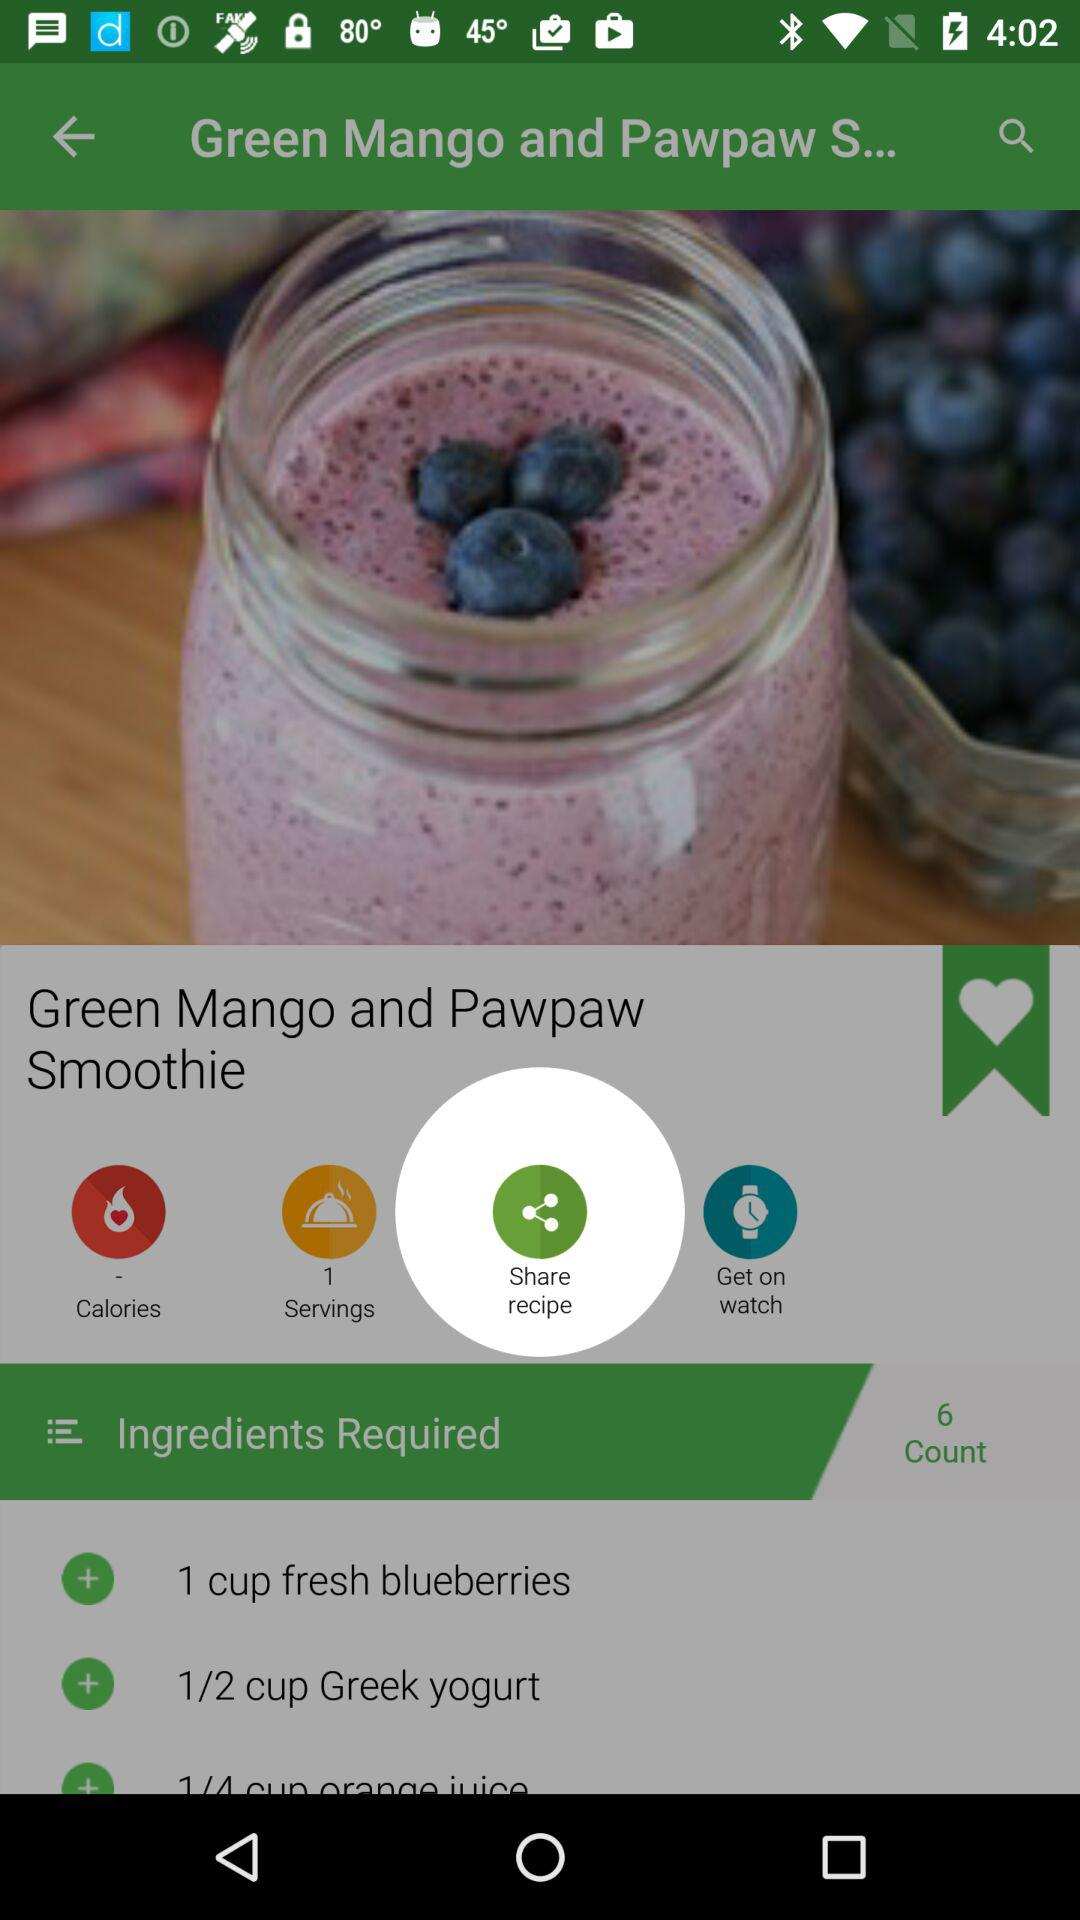What is the count? The count is 6. 